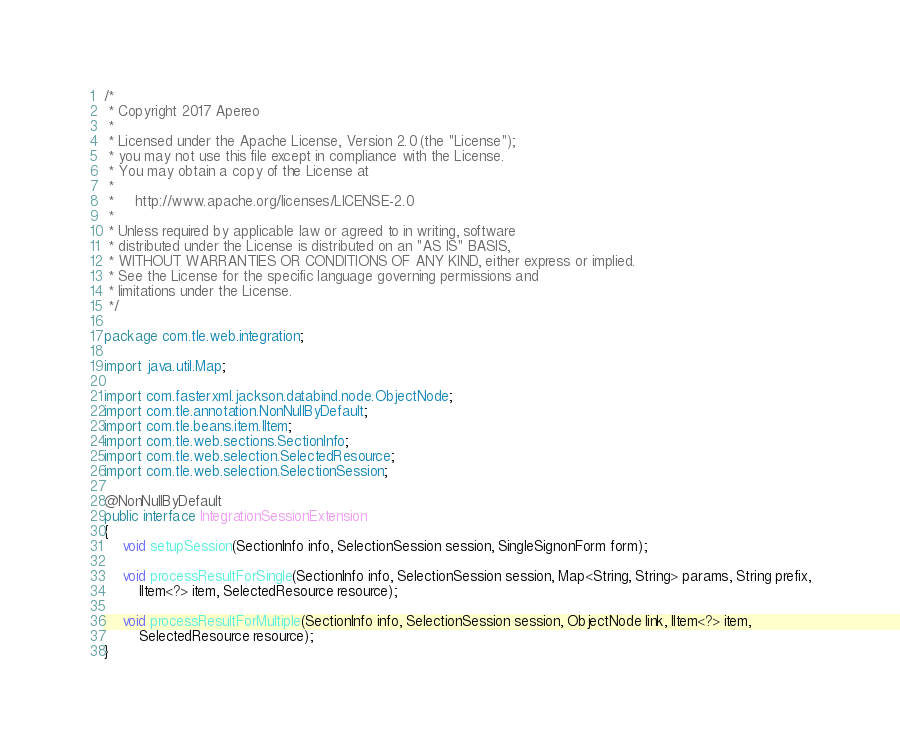Convert code to text. <code><loc_0><loc_0><loc_500><loc_500><_Java_>/*
 * Copyright 2017 Apereo
 *
 * Licensed under the Apache License, Version 2.0 (the "License");
 * you may not use this file except in compliance with the License.
 * You may obtain a copy of the License at
 *
 *     http://www.apache.org/licenses/LICENSE-2.0
 *
 * Unless required by applicable law or agreed to in writing, software
 * distributed under the License is distributed on an "AS IS" BASIS,
 * WITHOUT WARRANTIES OR CONDITIONS OF ANY KIND, either express or implied.
 * See the License for the specific language governing permissions and
 * limitations under the License.
 */

package com.tle.web.integration;

import java.util.Map;

import com.fasterxml.jackson.databind.node.ObjectNode;
import com.tle.annotation.NonNullByDefault;
import com.tle.beans.item.IItem;
import com.tle.web.sections.SectionInfo;
import com.tle.web.selection.SelectedResource;
import com.tle.web.selection.SelectionSession;

@NonNullByDefault
public interface IntegrationSessionExtension
{
	void setupSession(SectionInfo info, SelectionSession session, SingleSignonForm form);

	void processResultForSingle(SectionInfo info, SelectionSession session, Map<String, String> params, String prefix,
		IItem<?> item, SelectedResource resource);

	void processResultForMultiple(SectionInfo info, SelectionSession session, ObjectNode link, IItem<?> item,
		SelectedResource resource);
}
</code> 